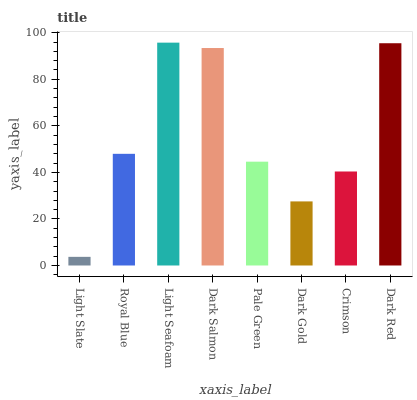Is Light Slate the minimum?
Answer yes or no. Yes. Is Light Seafoam the maximum?
Answer yes or no. Yes. Is Royal Blue the minimum?
Answer yes or no. No. Is Royal Blue the maximum?
Answer yes or no. No. Is Royal Blue greater than Light Slate?
Answer yes or no. Yes. Is Light Slate less than Royal Blue?
Answer yes or no. Yes. Is Light Slate greater than Royal Blue?
Answer yes or no. No. Is Royal Blue less than Light Slate?
Answer yes or no. No. Is Royal Blue the high median?
Answer yes or no. Yes. Is Pale Green the low median?
Answer yes or no. Yes. Is Dark Salmon the high median?
Answer yes or no. No. Is Dark Red the low median?
Answer yes or no. No. 